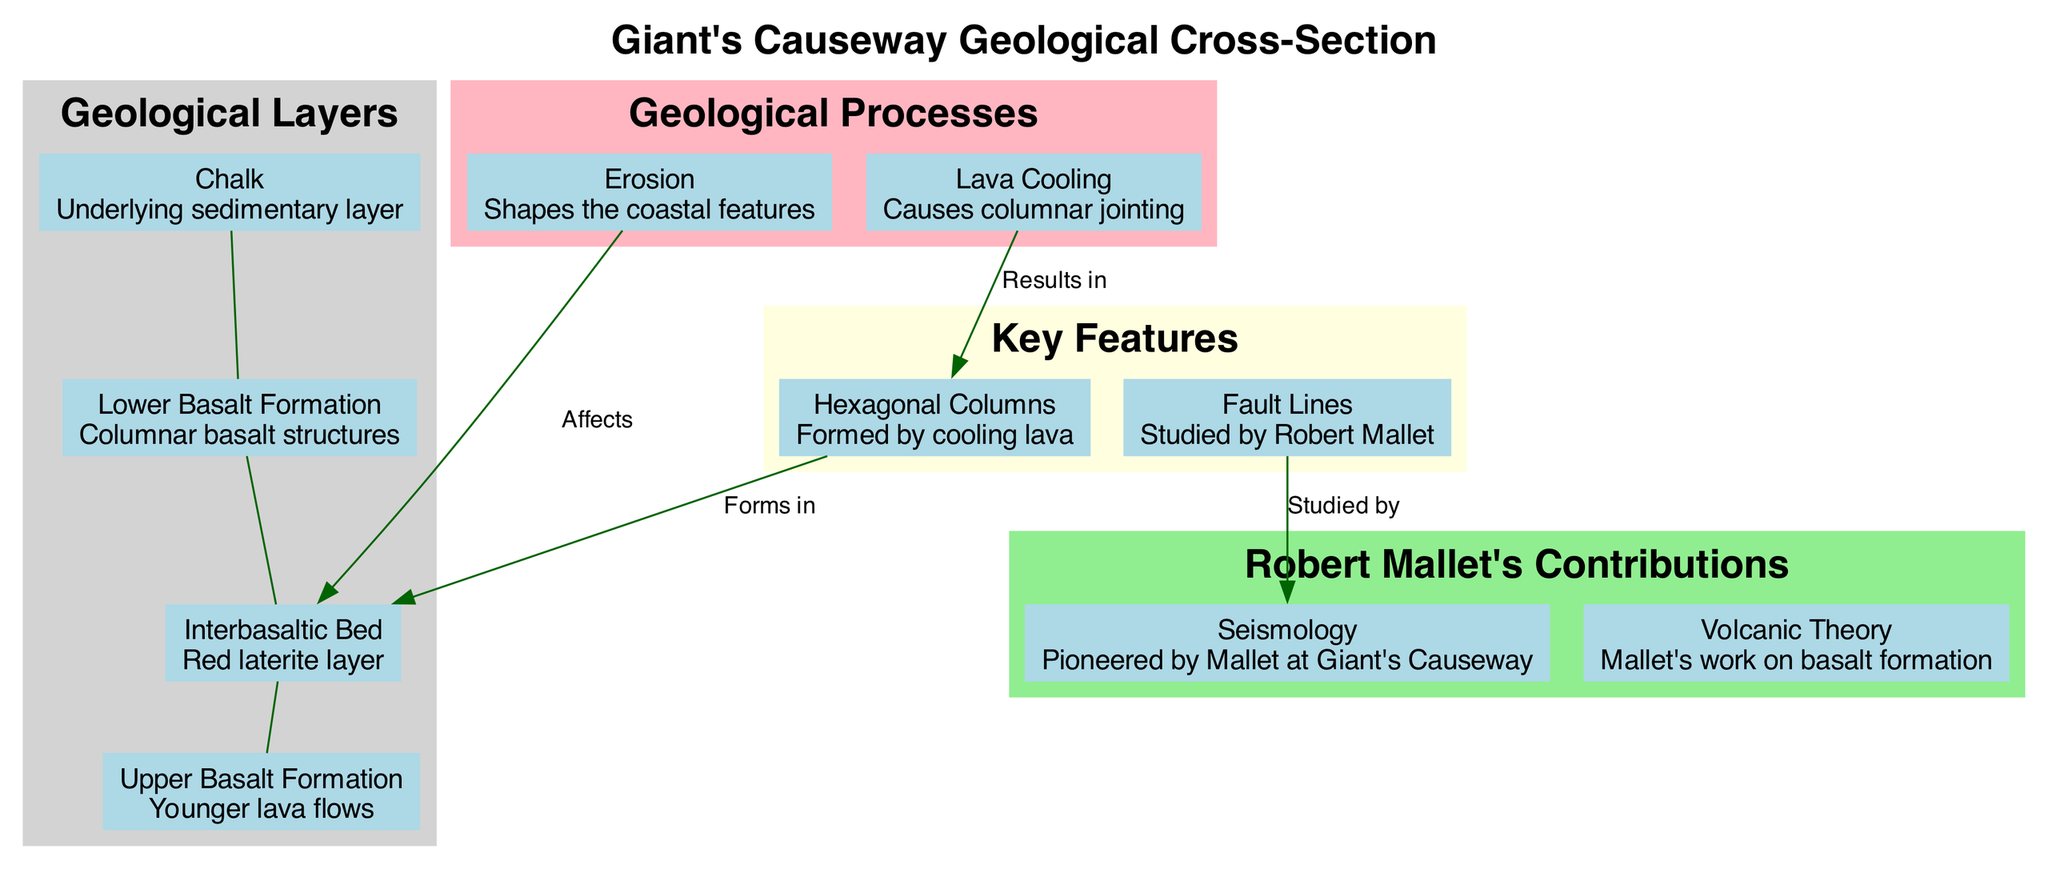What is the topmost layer in the geological cross-section? The diagram indicates the layers of the geological cross-section from top to bottom, where the first layer listed is the "Upper Basalt Formation." Therefore, it is the topmost layer.
Answer: Upper Basalt Formation How many geological layers are present in the cross-section? The diagram presents a total of four geological layers listed under the "Geological Layers" section. This includes the Upper Basalt Formation, Interbasaltic Bed, Lower Basalt Formation, and Chalk. Thus, the count is four.
Answer: 4 What type of structures are formed by cooling lava? In the "Key Features" section of the diagram, cooling lava is explicitly associated with the formation of "Hexagonal Columns." This is a direct correlation within the diagram.
Answer: Hexagonal Columns Which geological process affects the Lower Basalt Formation? The diagram shows that "Erosion" connects to the Lower Basalt Formation, indicating that this is the process affecting it. Hence, by examining the connections, we see that erosion directly impacts this layer.
Answer: Erosion How did Robert Mallet contribute to the scientific study of the Giant's Causeway? The diagram details Robert Mallet's contributions, highlighting "Seismology" and "Volcanic Theory." By evaluating the "Robert Mallet's Contributions" section, we can conclude that his involvement in both seismology and volcanic theory significantly advanced our understanding of this geological structure.
Answer: Seismology and Volcanic Theory What phenomenon results in the creation of hexagonal columns? Based on the diagram, the "Hexagonal Columns" are a result of the "Lava Cooling" process. The diagram shows a direct connection from lava cooling to the formation of these distinctive structures.
Answer: Lava Cooling Which layer serves as the basis for the geological cross-section? Looking at the list of layers, the "Chalk" is mentioned last and is positioned underneath the other layers, indicating it is the foundational or underlying layer of this geological cross-section.
Answer: Chalk What color represents the 'Key Features' section in the diagram? The diagram designates a light yellow color to the section that encapsulates the "Key Features." This can be verified visually by examining the coloring specified in the diagram legend.
Answer: Light Yellow 